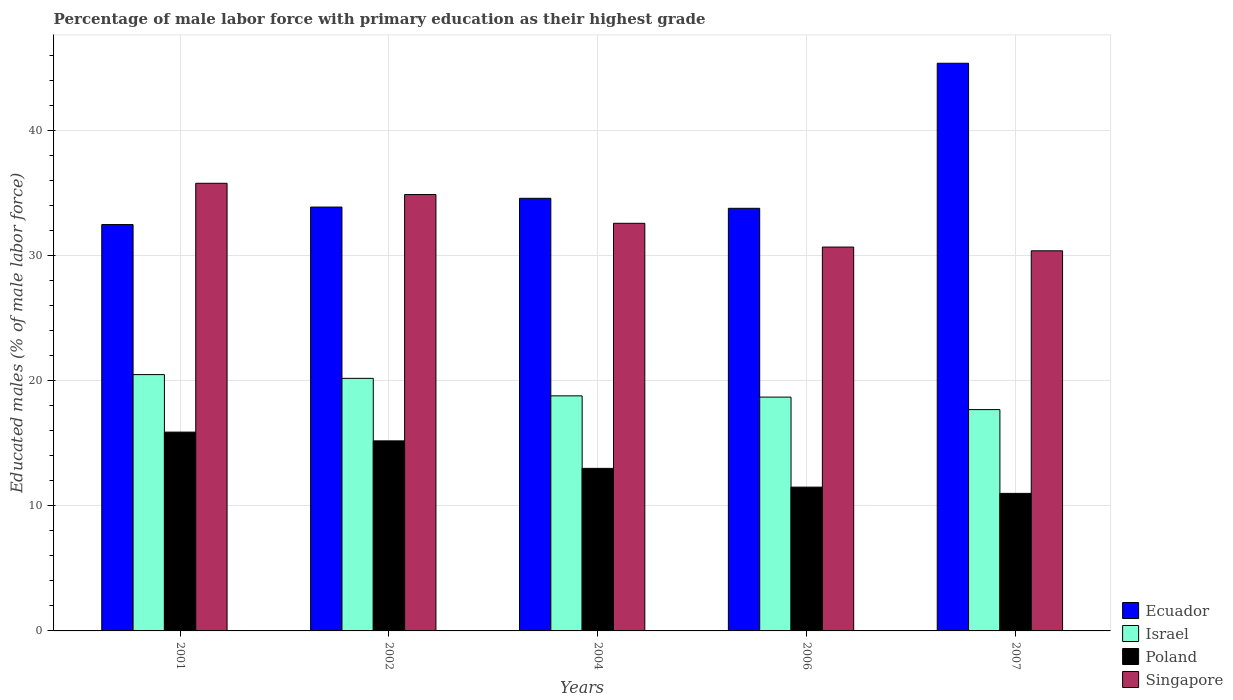How many different coloured bars are there?
Offer a terse response. 4. Are the number of bars on each tick of the X-axis equal?
Make the answer very short. Yes. What is the label of the 4th group of bars from the left?
Provide a succinct answer. 2006. What is the percentage of male labor force with primary education in Ecuador in 2006?
Offer a terse response. 33.8. Across all years, what is the maximum percentage of male labor force with primary education in Israel?
Ensure brevity in your answer.  20.5. Across all years, what is the minimum percentage of male labor force with primary education in Singapore?
Your answer should be very brief. 30.4. In which year was the percentage of male labor force with primary education in Singapore minimum?
Provide a short and direct response. 2007. What is the total percentage of male labor force with primary education in Poland in the graph?
Ensure brevity in your answer.  66.6. What is the difference between the percentage of male labor force with primary education in Poland in 2002 and that in 2006?
Your response must be concise. 3.7. What is the difference between the percentage of male labor force with primary education in Poland in 2007 and the percentage of male labor force with primary education in Ecuador in 2001?
Keep it short and to the point. -21.5. What is the average percentage of male labor force with primary education in Singapore per year?
Give a very brief answer. 32.88. What is the ratio of the percentage of male labor force with primary education in Singapore in 2001 to that in 2004?
Keep it short and to the point. 1.1. Is the percentage of male labor force with primary education in Ecuador in 2002 less than that in 2004?
Give a very brief answer. Yes. What is the difference between the highest and the second highest percentage of male labor force with primary education in Israel?
Provide a succinct answer. 0.3. What is the difference between the highest and the lowest percentage of male labor force with primary education in Israel?
Offer a very short reply. 2.8. Is the sum of the percentage of male labor force with primary education in Israel in 2002 and 2004 greater than the maximum percentage of male labor force with primary education in Poland across all years?
Your response must be concise. Yes. Is it the case that in every year, the sum of the percentage of male labor force with primary education in Poland and percentage of male labor force with primary education in Ecuador is greater than the sum of percentage of male labor force with primary education in Israel and percentage of male labor force with primary education in Singapore?
Your response must be concise. No. What does the 1st bar from the left in 2001 represents?
Your answer should be compact. Ecuador. Is it the case that in every year, the sum of the percentage of male labor force with primary education in Ecuador and percentage of male labor force with primary education in Poland is greater than the percentage of male labor force with primary education in Israel?
Give a very brief answer. Yes. Does the graph contain any zero values?
Make the answer very short. No. How are the legend labels stacked?
Your answer should be very brief. Vertical. What is the title of the graph?
Offer a terse response. Percentage of male labor force with primary education as their highest grade. What is the label or title of the X-axis?
Your response must be concise. Years. What is the label or title of the Y-axis?
Your response must be concise. Educated males (% of male labor force). What is the Educated males (% of male labor force) in Ecuador in 2001?
Your answer should be very brief. 32.5. What is the Educated males (% of male labor force) of Poland in 2001?
Your response must be concise. 15.9. What is the Educated males (% of male labor force) in Singapore in 2001?
Make the answer very short. 35.8. What is the Educated males (% of male labor force) in Ecuador in 2002?
Provide a short and direct response. 33.9. What is the Educated males (% of male labor force) in Israel in 2002?
Your answer should be compact. 20.2. What is the Educated males (% of male labor force) of Poland in 2002?
Make the answer very short. 15.2. What is the Educated males (% of male labor force) of Singapore in 2002?
Your answer should be very brief. 34.9. What is the Educated males (% of male labor force) of Ecuador in 2004?
Your answer should be very brief. 34.6. What is the Educated males (% of male labor force) of Israel in 2004?
Make the answer very short. 18.8. What is the Educated males (% of male labor force) in Singapore in 2004?
Make the answer very short. 32.6. What is the Educated males (% of male labor force) in Ecuador in 2006?
Provide a succinct answer. 33.8. What is the Educated males (% of male labor force) of Israel in 2006?
Your response must be concise. 18.7. What is the Educated males (% of male labor force) of Poland in 2006?
Ensure brevity in your answer.  11.5. What is the Educated males (% of male labor force) of Singapore in 2006?
Your response must be concise. 30.7. What is the Educated males (% of male labor force) of Ecuador in 2007?
Keep it short and to the point. 45.4. What is the Educated males (% of male labor force) in Israel in 2007?
Provide a short and direct response. 17.7. What is the Educated males (% of male labor force) of Singapore in 2007?
Make the answer very short. 30.4. Across all years, what is the maximum Educated males (% of male labor force) of Ecuador?
Ensure brevity in your answer.  45.4. Across all years, what is the maximum Educated males (% of male labor force) in Israel?
Give a very brief answer. 20.5. Across all years, what is the maximum Educated males (% of male labor force) in Poland?
Ensure brevity in your answer.  15.9. Across all years, what is the maximum Educated males (% of male labor force) in Singapore?
Ensure brevity in your answer.  35.8. Across all years, what is the minimum Educated males (% of male labor force) of Ecuador?
Give a very brief answer. 32.5. Across all years, what is the minimum Educated males (% of male labor force) of Israel?
Give a very brief answer. 17.7. Across all years, what is the minimum Educated males (% of male labor force) in Singapore?
Offer a terse response. 30.4. What is the total Educated males (% of male labor force) of Ecuador in the graph?
Make the answer very short. 180.2. What is the total Educated males (% of male labor force) of Israel in the graph?
Your answer should be very brief. 95.9. What is the total Educated males (% of male labor force) in Poland in the graph?
Offer a terse response. 66.6. What is the total Educated males (% of male labor force) in Singapore in the graph?
Provide a succinct answer. 164.4. What is the difference between the Educated males (% of male labor force) of Israel in 2001 and that in 2002?
Keep it short and to the point. 0.3. What is the difference between the Educated males (% of male labor force) in Poland in 2001 and that in 2002?
Provide a short and direct response. 0.7. What is the difference between the Educated males (% of male labor force) of Singapore in 2001 and that in 2002?
Provide a short and direct response. 0.9. What is the difference between the Educated males (% of male labor force) of Ecuador in 2001 and that in 2004?
Provide a succinct answer. -2.1. What is the difference between the Educated males (% of male labor force) of Israel in 2001 and that in 2004?
Provide a succinct answer. 1.7. What is the difference between the Educated males (% of male labor force) of Ecuador in 2001 and that in 2006?
Keep it short and to the point. -1.3. What is the difference between the Educated males (% of male labor force) in Poland in 2001 and that in 2006?
Your response must be concise. 4.4. What is the difference between the Educated males (% of male labor force) of Singapore in 2001 and that in 2006?
Offer a very short reply. 5.1. What is the difference between the Educated males (% of male labor force) in Poland in 2001 and that in 2007?
Provide a succinct answer. 4.9. What is the difference between the Educated males (% of male labor force) of Singapore in 2001 and that in 2007?
Offer a very short reply. 5.4. What is the difference between the Educated males (% of male labor force) of Poland in 2002 and that in 2004?
Ensure brevity in your answer.  2.2. What is the difference between the Educated males (% of male labor force) of Israel in 2002 and that in 2006?
Offer a terse response. 1.5. What is the difference between the Educated males (% of male labor force) of Poland in 2002 and that in 2006?
Offer a very short reply. 3.7. What is the difference between the Educated males (% of male labor force) of Israel in 2004 and that in 2006?
Your response must be concise. 0.1. What is the difference between the Educated males (% of male labor force) of Israel in 2004 and that in 2007?
Ensure brevity in your answer.  1.1. What is the difference between the Educated males (% of male labor force) in Poland in 2004 and that in 2007?
Provide a succinct answer. 2. What is the difference between the Educated males (% of male labor force) of Ecuador in 2006 and that in 2007?
Your answer should be very brief. -11.6. What is the difference between the Educated males (% of male labor force) in Israel in 2006 and that in 2007?
Offer a terse response. 1. What is the difference between the Educated males (% of male labor force) in Ecuador in 2001 and the Educated males (% of male labor force) in Israel in 2002?
Offer a terse response. 12.3. What is the difference between the Educated males (% of male labor force) of Israel in 2001 and the Educated males (% of male labor force) of Poland in 2002?
Make the answer very short. 5.3. What is the difference between the Educated males (% of male labor force) of Israel in 2001 and the Educated males (% of male labor force) of Singapore in 2002?
Give a very brief answer. -14.4. What is the difference between the Educated males (% of male labor force) of Ecuador in 2001 and the Educated males (% of male labor force) of Poland in 2004?
Your response must be concise. 19.5. What is the difference between the Educated males (% of male labor force) in Ecuador in 2001 and the Educated males (% of male labor force) in Singapore in 2004?
Offer a very short reply. -0.1. What is the difference between the Educated males (% of male labor force) in Poland in 2001 and the Educated males (% of male labor force) in Singapore in 2004?
Ensure brevity in your answer.  -16.7. What is the difference between the Educated males (% of male labor force) of Ecuador in 2001 and the Educated males (% of male labor force) of Poland in 2006?
Your answer should be compact. 21. What is the difference between the Educated males (% of male labor force) of Ecuador in 2001 and the Educated males (% of male labor force) of Singapore in 2006?
Your response must be concise. 1.8. What is the difference between the Educated males (% of male labor force) in Israel in 2001 and the Educated males (% of male labor force) in Poland in 2006?
Your response must be concise. 9. What is the difference between the Educated males (% of male labor force) of Israel in 2001 and the Educated males (% of male labor force) of Singapore in 2006?
Offer a terse response. -10.2. What is the difference between the Educated males (% of male labor force) in Poland in 2001 and the Educated males (% of male labor force) in Singapore in 2006?
Your answer should be compact. -14.8. What is the difference between the Educated males (% of male labor force) in Israel in 2001 and the Educated males (% of male labor force) in Poland in 2007?
Your answer should be very brief. 9.5. What is the difference between the Educated males (% of male labor force) of Israel in 2001 and the Educated males (% of male labor force) of Singapore in 2007?
Your response must be concise. -9.9. What is the difference between the Educated males (% of male labor force) in Poland in 2001 and the Educated males (% of male labor force) in Singapore in 2007?
Your response must be concise. -14.5. What is the difference between the Educated males (% of male labor force) in Ecuador in 2002 and the Educated males (% of male labor force) in Poland in 2004?
Your response must be concise. 20.9. What is the difference between the Educated males (% of male labor force) in Israel in 2002 and the Educated males (% of male labor force) in Poland in 2004?
Offer a very short reply. 7.2. What is the difference between the Educated males (% of male labor force) in Israel in 2002 and the Educated males (% of male labor force) in Singapore in 2004?
Offer a terse response. -12.4. What is the difference between the Educated males (% of male labor force) in Poland in 2002 and the Educated males (% of male labor force) in Singapore in 2004?
Give a very brief answer. -17.4. What is the difference between the Educated males (% of male labor force) in Ecuador in 2002 and the Educated males (% of male labor force) in Poland in 2006?
Offer a very short reply. 22.4. What is the difference between the Educated males (% of male labor force) of Poland in 2002 and the Educated males (% of male labor force) of Singapore in 2006?
Your response must be concise. -15.5. What is the difference between the Educated males (% of male labor force) in Ecuador in 2002 and the Educated males (% of male labor force) in Israel in 2007?
Keep it short and to the point. 16.2. What is the difference between the Educated males (% of male labor force) in Ecuador in 2002 and the Educated males (% of male labor force) in Poland in 2007?
Offer a very short reply. 22.9. What is the difference between the Educated males (% of male labor force) in Israel in 2002 and the Educated males (% of male labor force) in Singapore in 2007?
Provide a short and direct response. -10.2. What is the difference between the Educated males (% of male labor force) of Poland in 2002 and the Educated males (% of male labor force) of Singapore in 2007?
Give a very brief answer. -15.2. What is the difference between the Educated males (% of male labor force) of Ecuador in 2004 and the Educated males (% of male labor force) of Poland in 2006?
Your response must be concise. 23.1. What is the difference between the Educated males (% of male labor force) in Israel in 2004 and the Educated males (% of male labor force) in Poland in 2006?
Offer a very short reply. 7.3. What is the difference between the Educated males (% of male labor force) in Poland in 2004 and the Educated males (% of male labor force) in Singapore in 2006?
Your answer should be compact. -17.7. What is the difference between the Educated males (% of male labor force) in Ecuador in 2004 and the Educated males (% of male labor force) in Poland in 2007?
Offer a terse response. 23.6. What is the difference between the Educated males (% of male labor force) of Israel in 2004 and the Educated males (% of male labor force) of Poland in 2007?
Make the answer very short. 7.8. What is the difference between the Educated males (% of male labor force) of Israel in 2004 and the Educated males (% of male labor force) of Singapore in 2007?
Ensure brevity in your answer.  -11.6. What is the difference between the Educated males (% of male labor force) of Poland in 2004 and the Educated males (% of male labor force) of Singapore in 2007?
Offer a terse response. -17.4. What is the difference between the Educated males (% of male labor force) of Ecuador in 2006 and the Educated males (% of male labor force) of Israel in 2007?
Provide a short and direct response. 16.1. What is the difference between the Educated males (% of male labor force) in Ecuador in 2006 and the Educated males (% of male labor force) in Poland in 2007?
Your response must be concise. 22.8. What is the difference between the Educated males (% of male labor force) of Ecuador in 2006 and the Educated males (% of male labor force) of Singapore in 2007?
Give a very brief answer. 3.4. What is the difference between the Educated males (% of male labor force) in Poland in 2006 and the Educated males (% of male labor force) in Singapore in 2007?
Provide a succinct answer. -18.9. What is the average Educated males (% of male labor force) of Ecuador per year?
Your answer should be very brief. 36.04. What is the average Educated males (% of male labor force) of Israel per year?
Make the answer very short. 19.18. What is the average Educated males (% of male labor force) of Poland per year?
Provide a short and direct response. 13.32. What is the average Educated males (% of male labor force) of Singapore per year?
Provide a short and direct response. 32.88. In the year 2001, what is the difference between the Educated males (% of male labor force) of Ecuador and Educated males (% of male labor force) of Singapore?
Ensure brevity in your answer.  -3.3. In the year 2001, what is the difference between the Educated males (% of male labor force) in Israel and Educated males (% of male labor force) in Poland?
Offer a terse response. 4.6. In the year 2001, what is the difference between the Educated males (% of male labor force) of Israel and Educated males (% of male labor force) of Singapore?
Provide a succinct answer. -15.3. In the year 2001, what is the difference between the Educated males (% of male labor force) of Poland and Educated males (% of male labor force) of Singapore?
Keep it short and to the point. -19.9. In the year 2002, what is the difference between the Educated males (% of male labor force) in Ecuador and Educated males (% of male labor force) in Poland?
Your response must be concise. 18.7. In the year 2002, what is the difference between the Educated males (% of male labor force) of Ecuador and Educated males (% of male labor force) of Singapore?
Provide a succinct answer. -1. In the year 2002, what is the difference between the Educated males (% of male labor force) of Israel and Educated males (% of male labor force) of Singapore?
Keep it short and to the point. -14.7. In the year 2002, what is the difference between the Educated males (% of male labor force) in Poland and Educated males (% of male labor force) in Singapore?
Make the answer very short. -19.7. In the year 2004, what is the difference between the Educated males (% of male labor force) in Ecuador and Educated males (% of male labor force) in Poland?
Offer a very short reply. 21.6. In the year 2004, what is the difference between the Educated males (% of male labor force) of Ecuador and Educated males (% of male labor force) of Singapore?
Your response must be concise. 2. In the year 2004, what is the difference between the Educated males (% of male labor force) of Israel and Educated males (% of male labor force) of Poland?
Offer a terse response. 5.8. In the year 2004, what is the difference between the Educated males (% of male labor force) of Poland and Educated males (% of male labor force) of Singapore?
Your response must be concise. -19.6. In the year 2006, what is the difference between the Educated males (% of male labor force) of Ecuador and Educated males (% of male labor force) of Israel?
Provide a short and direct response. 15.1. In the year 2006, what is the difference between the Educated males (% of male labor force) in Ecuador and Educated males (% of male labor force) in Poland?
Your response must be concise. 22.3. In the year 2006, what is the difference between the Educated males (% of male labor force) in Israel and Educated males (% of male labor force) in Poland?
Provide a succinct answer. 7.2. In the year 2006, what is the difference between the Educated males (% of male labor force) in Poland and Educated males (% of male labor force) in Singapore?
Give a very brief answer. -19.2. In the year 2007, what is the difference between the Educated males (% of male labor force) in Ecuador and Educated males (% of male labor force) in Israel?
Your answer should be very brief. 27.7. In the year 2007, what is the difference between the Educated males (% of male labor force) of Ecuador and Educated males (% of male labor force) of Poland?
Your answer should be compact. 34.4. In the year 2007, what is the difference between the Educated males (% of male labor force) in Ecuador and Educated males (% of male labor force) in Singapore?
Offer a terse response. 15. In the year 2007, what is the difference between the Educated males (% of male labor force) in Israel and Educated males (% of male labor force) in Poland?
Provide a short and direct response. 6.7. In the year 2007, what is the difference between the Educated males (% of male labor force) in Poland and Educated males (% of male labor force) in Singapore?
Your answer should be very brief. -19.4. What is the ratio of the Educated males (% of male labor force) of Ecuador in 2001 to that in 2002?
Ensure brevity in your answer.  0.96. What is the ratio of the Educated males (% of male labor force) of Israel in 2001 to that in 2002?
Provide a succinct answer. 1.01. What is the ratio of the Educated males (% of male labor force) of Poland in 2001 to that in 2002?
Provide a short and direct response. 1.05. What is the ratio of the Educated males (% of male labor force) of Singapore in 2001 to that in 2002?
Your answer should be compact. 1.03. What is the ratio of the Educated males (% of male labor force) in Ecuador in 2001 to that in 2004?
Provide a short and direct response. 0.94. What is the ratio of the Educated males (% of male labor force) of Israel in 2001 to that in 2004?
Ensure brevity in your answer.  1.09. What is the ratio of the Educated males (% of male labor force) of Poland in 2001 to that in 2004?
Your response must be concise. 1.22. What is the ratio of the Educated males (% of male labor force) in Singapore in 2001 to that in 2004?
Ensure brevity in your answer.  1.1. What is the ratio of the Educated males (% of male labor force) in Ecuador in 2001 to that in 2006?
Your answer should be very brief. 0.96. What is the ratio of the Educated males (% of male labor force) of Israel in 2001 to that in 2006?
Give a very brief answer. 1.1. What is the ratio of the Educated males (% of male labor force) of Poland in 2001 to that in 2006?
Offer a terse response. 1.38. What is the ratio of the Educated males (% of male labor force) in Singapore in 2001 to that in 2006?
Give a very brief answer. 1.17. What is the ratio of the Educated males (% of male labor force) of Ecuador in 2001 to that in 2007?
Give a very brief answer. 0.72. What is the ratio of the Educated males (% of male labor force) in Israel in 2001 to that in 2007?
Offer a very short reply. 1.16. What is the ratio of the Educated males (% of male labor force) of Poland in 2001 to that in 2007?
Make the answer very short. 1.45. What is the ratio of the Educated males (% of male labor force) in Singapore in 2001 to that in 2007?
Your answer should be very brief. 1.18. What is the ratio of the Educated males (% of male labor force) in Ecuador in 2002 to that in 2004?
Your answer should be very brief. 0.98. What is the ratio of the Educated males (% of male labor force) in Israel in 2002 to that in 2004?
Your answer should be very brief. 1.07. What is the ratio of the Educated males (% of male labor force) in Poland in 2002 to that in 2004?
Make the answer very short. 1.17. What is the ratio of the Educated males (% of male labor force) in Singapore in 2002 to that in 2004?
Give a very brief answer. 1.07. What is the ratio of the Educated males (% of male labor force) in Ecuador in 2002 to that in 2006?
Ensure brevity in your answer.  1. What is the ratio of the Educated males (% of male labor force) of Israel in 2002 to that in 2006?
Your response must be concise. 1.08. What is the ratio of the Educated males (% of male labor force) of Poland in 2002 to that in 2006?
Make the answer very short. 1.32. What is the ratio of the Educated males (% of male labor force) in Singapore in 2002 to that in 2006?
Ensure brevity in your answer.  1.14. What is the ratio of the Educated males (% of male labor force) of Ecuador in 2002 to that in 2007?
Offer a very short reply. 0.75. What is the ratio of the Educated males (% of male labor force) of Israel in 2002 to that in 2007?
Provide a short and direct response. 1.14. What is the ratio of the Educated males (% of male labor force) of Poland in 2002 to that in 2007?
Offer a very short reply. 1.38. What is the ratio of the Educated males (% of male labor force) in Singapore in 2002 to that in 2007?
Your answer should be very brief. 1.15. What is the ratio of the Educated males (% of male labor force) of Ecuador in 2004 to that in 2006?
Ensure brevity in your answer.  1.02. What is the ratio of the Educated males (% of male labor force) in Israel in 2004 to that in 2006?
Offer a very short reply. 1.01. What is the ratio of the Educated males (% of male labor force) of Poland in 2004 to that in 2006?
Offer a very short reply. 1.13. What is the ratio of the Educated males (% of male labor force) of Singapore in 2004 to that in 2006?
Keep it short and to the point. 1.06. What is the ratio of the Educated males (% of male labor force) in Ecuador in 2004 to that in 2007?
Give a very brief answer. 0.76. What is the ratio of the Educated males (% of male labor force) in Israel in 2004 to that in 2007?
Your response must be concise. 1.06. What is the ratio of the Educated males (% of male labor force) in Poland in 2004 to that in 2007?
Provide a succinct answer. 1.18. What is the ratio of the Educated males (% of male labor force) in Singapore in 2004 to that in 2007?
Your answer should be compact. 1.07. What is the ratio of the Educated males (% of male labor force) in Ecuador in 2006 to that in 2007?
Your response must be concise. 0.74. What is the ratio of the Educated males (% of male labor force) in Israel in 2006 to that in 2007?
Offer a very short reply. 1.06. What is the ratio of the Educated males (% of male labor force) in Poland in 2006 to that in 2007?
Keep it short and to the point. 1.05. What is the ratio of the Educated males (% of male labor force) in Singapore in 2006 to that in 2007?
Give a very brief answer. 1.01. What is the difference between the highest and the second highest Educated males (% of male labor force) in Israel?
Ensure brevity in your answer.  0.3. What is the difference between the highest and the lowest Educated males (% of male labor force) of Israel?
Keep it short and to the point. 2.8. 